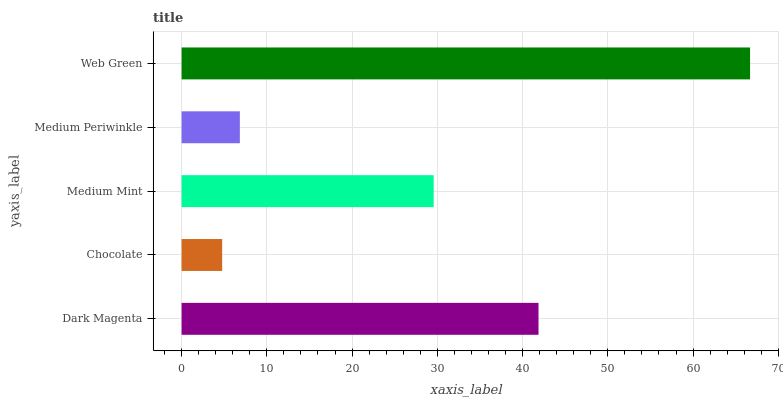Is Chocolate the minimum?
Answer yes or no. Yes. Is Web Green the maximum?
Answer yes or no. Yes. Is Medium Mint the minimum?
Answer yes or no. No. Is Medium Mint the maximum?
Answer yes or no. No. Is Medium Mint greater than Chocolate?
Answer yes or no. Yes. Is Chocolate less than Medium Mint?
Answer yes or no. Yes. Is Chocolate greater than Medium Mint?
Answer yes or no. No. Is Medium Mint less than Chocolate?
Answer yes or no. No. Is Medium Mint the high median?
Answer yes or no. Yes. Is Medium Mint the low median?
Answer yes or no. Yes. Is Dark Magenta the high median?
Answer yes or no. No. Is Chocolate the low median?
Answer yes or no. No. 